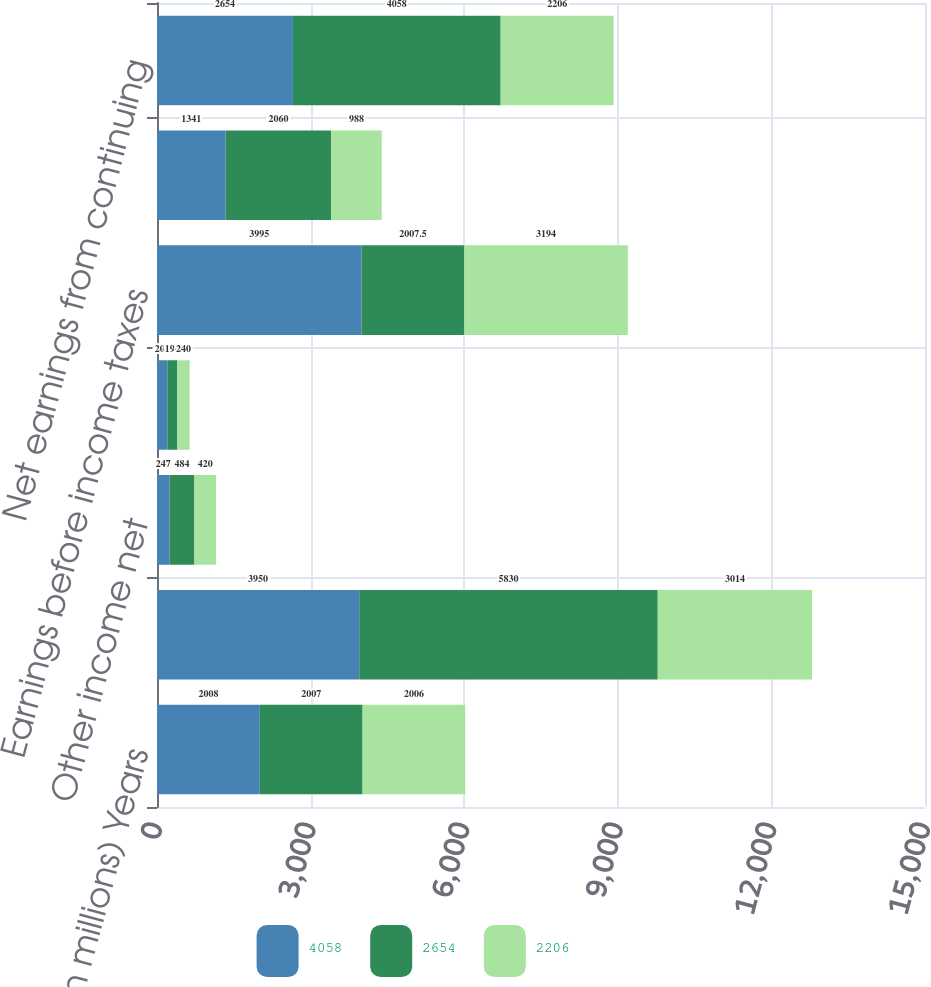Convert chart. <chart><loc_0><loc_0><loc_500><loc_500><stacked_bar_chart><ecel><fcel>(Dollars in millions) Years<fcel>Earnings from operations<fcel>Other income net<fcel>Interest and debt expense<fcel>Earnings before income taxes<fcel>Income tax expense<fcel>Net earnings from continuing<nl><fcel>4058<fcel>2008<fcel>3950<fcel>247<fcel>202<fcel>3995<fcel>1341<fcel>2654<nl><fcel>2654<fcel>2007<fcel>5830<fcel>484<fcel>196<fcel>2007.5<fcel>2060<fcel>4058<nl><fcel>2206<fcel>2006<fcel>3014<fcel>420<fcel>240<fcel>3194<fcel>988<fcel>2206<nl></chart> 